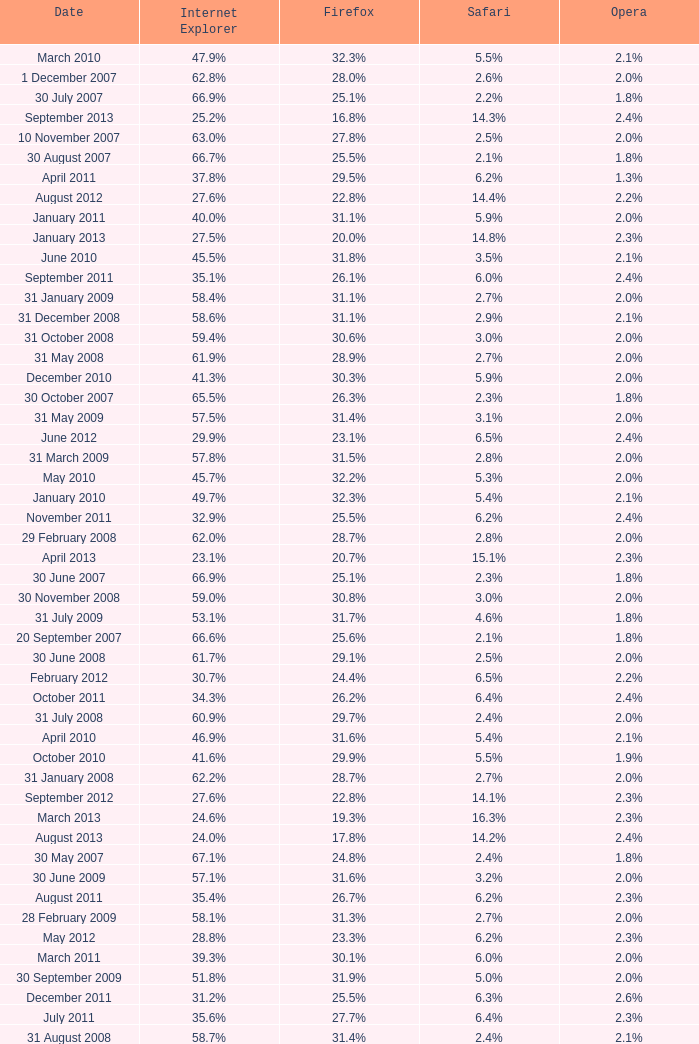What is the firefox importance with a 2 19.2%. 